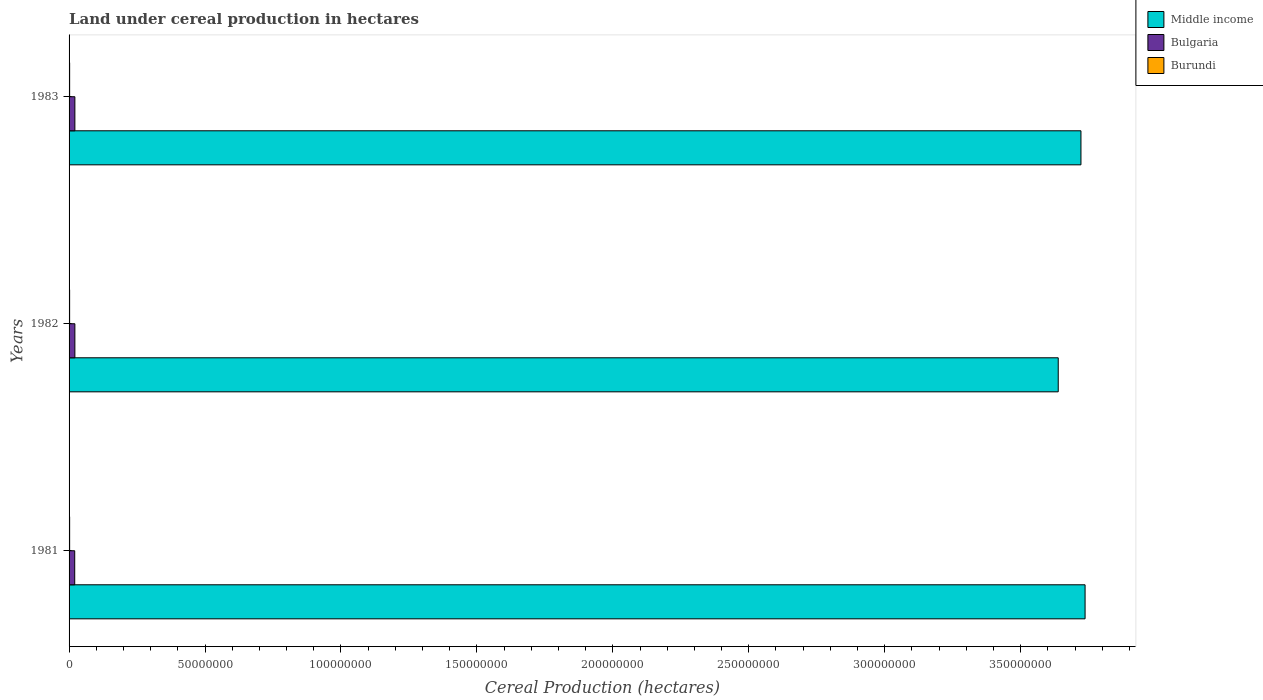How many different coloured bars are there?
Your answer should be very brief. 3. Are the number of bars per tick equal to the number of legend labels?
Offer a very short reply. Yes. Are the number of bars on each tick of the Y-axis equal?
Offer a very short reply. Yes. What is the label of the 3rd group of bars from the top?
Provide a short and direct response. 1981. What is the land under cereal production in Middle income in 1981?
Make the answer very short. 3.74e+08. Across all years, what is the maximum land under cereal production in Burundi?
Make the answer very short. 2.10e+05. Across all years, what is the minimum land under cereal production in Burundi?
Keep it short and to the point. 2.06e+05. What is the total land under cereal production in Middle income in the graph?
Keep it short and to the point. 1.11e+09. What is the difference between the land under cereal production in Bulgaria in 1981 and that in 1982?
Your answer should be compact. -5.45e+04. What is the difference between the land under cereal production in Middle income in 1981 and the land under cereal production in Bulgaria in 1983?
Your answer should be compact. 3.72e+08. What is the average land under cereal production in Middle income per year?
Ensure brevity in your answer.  3.70e+08. In the year 1982, what is the difference between the land under cereal production in Middle income and land under cereal production in Bulgaria?
Make the answer very short. 3.62e+08. What is the ratio of the land under cereal production in Bulgaria in 1982 to that in 1983?
Offer a very short reply. 1. Is the land under cereal production in Burundi in 1981 less than that in 1983?
Give a very brief answer. No. What is the difference between the highest and the second highest land under cereal production in Burundi?
Make the answer very short. 2602. What is the difference between the highest and the lowest land under cereal production in Burundi?
Ensure brevity in your answer.  4602. Is the sum of the land under cereal production in Middle income in 1982 and 1983 greater than the maximum land under cereal production in Burundi across all years?
Make the answer very short. Yes. What does the 1st bar from the top in 1983 represents?
Provide a short and direct response. Burundi. What does the 3rd bar from the bottom in 1983 represents?
Ensure brevity in your answer.  Burundi. Is it the case that in every year, the sum of the land under cereal production in Burundi and land under cereal production in Middle income is greater than the land under cereal production in Bulgaria?
Make the answer very short. Yes. How many bars are there?
Your answer should be very brief. 9. Are all the bars in the graph horizontal?
Keep it short and to the point. Yes. How many years are there in the graph?
Keep it short and to the point. 3. Are the values on the major ticks of X-axis written in scientific E-notation?
Give a very brief answer. No. Does the graph contain any zero values?
Offer a terse response. No. Does the graph contain grids?
Provide a short and direct response. No. What is the title of the graph?
Keep it short and to the point. Land under cereal production in hectares. Does "Dominican Republic" appear as one of the legend labels in the graph?
Your response must be concise. No. What is the label or title of the X-axis?
Give a very brief answer. Cereal Production (hectares). What is the label or title of the Y-axis?
Make the answer very short. Years. What is the Cereal Production (hectares) of Middle income in 1981?
Keep it short and to the point. 3.74e+08. What is the Cereal Production (hectares) in Bulgaria in 1981?
Your answer should be compact. 2.08e+06. What is the Cereal Production (hectares) of Burundi in 1981?
Your answer should be compact. 2.10e+05. What is the Cereal Production (hectares) in Middle income in 1982?
Keep it short and to the point. 3.64e+08. What is the Cereal Production (hectares) of Bulgaria in 1982?
Provide a short and direct response. 2.13e+06. What is the Cereal Production (hectares) in Burundi in 1982?
Your response must be concise. 2.06e+05. What is the Cereal Production (hectares) in Middle income in 1983?
Your answer should be compact. 3.72e+08. What is the Cereal Production (hectares) of Bulgaria in 1983?
Ensure brevity in your answer.  2.13e+06. What is the Cereal Production (hectares) of Burundi in 1983?
Offer a very short reply. 2.08e+05. Across all years, what is the maximum Cereal Production (hectares) in Middle income?
Your answer should be very brief. 3.74e+08. Across all years, what is the maximum Cereal Production (hectares) of Bulgaria?
Your answer should be compact. 2.13e+06. Across all years, what is the maximum Cereal Production (hectares) of Burundi?
Keep it short and to the point. 2.10e+05. Across all years, what is the minimum Cereal Production (hectares) in Middle income?
Offer a very short reply. 3.64e+08. Across all years, what is the minimum Cereal Production (hectares) in Bulgaria?
Your answer should be very brief. 2.08e+06. Across all years, what is the minimum Cereal Production (hectares) of Burundi?
Make the answer very short. 2.06e+05. What is the total Cereal Production (hectares) of Middle income in the graph?
Ensure brevity in your answer.  1.11e+09. What is the total Cereal Production (hectares) of Bulgaria in the graph?
Ensure brevity in your answer.  6.35e+06. What is the total Cereal Production (hectares) in Burundi in the graph?
Give a very brief answer. 6.23e+05. What is the difference between the Cereal Production (hectares) in Middle income in 1981 and that in 1982?
Give a very brief answer. 9.87e+06. What is the difference between the Cereal Production (hectares) of Bulgaria in 1981 and that in 1982?
Offer a terse response. -5.45e+04. What is the difference between the Cereal Production (hectares) in Burundi in 1981 and that in 1982?
Offer a very short reply. 4602. What is the difference between the Cereal Production (hectares) in Middle income in 1981 and that in 1983?
Give a very brief answer. 1.52e+06. What is the difference between the Cereal Production (hectares) in Bulgaria in 1981 and that in 1983?
Your answer should be compact. -5.38e+04. What is the difference between the Cereal Production (hectares) of Burundi in 1981 and that in 1983?
Your answer should be compact. 2602. What is the difference between the Cereal Production (hectares) in Middle income in 1982 and that in 1983?
Provide a short and direct response. -8.36e+06. What is the difference between the Cereal Production (hectares) in Bulgaria in 1982 and that in 1983?
Keep it short and to the point. 752. What is the difference between the Cereal Production (hectares) of Burundi in 1982 and that in 1983?
Ensure brevity in your answer.  -2000. What is the difference between the Cereal Production (hectares) in Middle income in 1981 and the Cereal Production (hectares) in Bulgaria in 1982?
Offer a terse response. 3.72e+08. What is the difference between the Cereal Production (hectares) of Middle income in 1981 and the Cereal Production (hectares) of Burundi in 1982?
Offer a very short reply. 3.74e+08. What is the difference between the Cereal Production (hectares) in Bulgaria in 1981 and the Cereal Production (hectares) in Burundi in 1982?
Ensure brevity in your answer.  1.87e+06. What is the difference between the Cereal Production (hectares) of Middle income in 1981 and the Cereal Production (hectares) of Bulgaria in 1983?
Provide a succinct answer. 3.72e+08. What is the difference between the Cereal Production (hectares) of Middle income in 1981 and the Cereal Production (hectares) of Burundi in 1983?
Provide a succinct answer. 3.74e+08. What is the difference between the Cereal Production (hectares) of Bulgaria in 1981 and the Cereal Production (hectares) of Burundi in 1983?
Keep it short and to the point. 1.87e+06. What is the difference between the Cereal Production (hectares) of Middle income in 1982 and the Cereal Production (hectares) of Bulgaria in 1983?
Make the answer very short. 3.62e+08. What is the difference between the Cereal Production (hectares) of Middle income in 1982 and the Cereal Production (hectares) of Burundi in 1983?
Offer a terse response. 3.64e+08. What is the difference between the Cereal Production (hectares) in Bulgaria in 1982 and the Cereal Production (hectares) in Burundi in 1983?
Give a very brief answer. 1.93e+06. What is the average Cereal Production (hectares) in Middle income per year?
Your answer should be compact. 3.70e+08. What is the average Cereal Production (hectares) of Bulgaria per year?
Offer a very short reply. 2.12e+06. What is the average Cereal Production (hectares) of Burundi per year?
Provide a short and direct response. 2.08e+05. In the year 1981, what is the difference between the Cereal Production (hectares) in Middle income and Cereal Production (hectares) in Bulgaria?
Provide a succinct answer. 3.72e+08. In the year 1981, what is the difference between the Cereal Production (hectares) in Middle income and Cereal Production (hectares) in Burundi?
Offer a very short reply. 3.73e+08. In the year 1981, what is the difference between the Cereal Production (hectares) of Bulgaria and Cereal Production (hectares) of Burundi?
Provide a short and direct response. 1.87e+06. In the year 1982, what is the difference between the Cereal Production (hectares) of Middle income and Cereal Production (hectares) of Bulgaria?
Your response must be concise. 3.62e+08. In the year 1982, what is the difference between the Cereal Production (hectares) in Middle income and Cereal Production (hectares) in Burundi?
Ensure brevity in your answer.  3.64e+08. In the year 1982, what is the difference between the Cereal Production (hectares) of Bulgaria and Cereal Production (hectares) of Burundi?
Keep it short and to the point. 1.93e+06. In the year 1983, what is the difference between the Cereal Production (hectares) of Middle income and Cereal Production (hectares) of Bulgaria?
Provide a succinct answer. 3.70e+08. In the year 1983, what is the difference between the Cereal Production (hectares) in Middle income and Cereal Production (hectares) in Burundi?
Give a very brief answer. 3.72e+08. In the year 1983, what is the difference between the Cereal Production (hectares) in Bulgaria and Cereal Production (hectares) in Burundi?
Provide a short and direct response. 1.93e+06. What is the ratio of the Cereal Production (hectares) of Middle income in 1981 to that in 1982?
Your answer should be very brief. 1.03. What is the ratio of the Cereal Production (hectares) of Bulgaria in 1981 to that in 1982?
Keep it short and to the point. 0.97. What is the ratio of the Cereal Production (hectares) of Burundi in 1981 to that in 1982?
Ensure brevity in your answer.  1.02. What is the ratio of the Cereal Production (hectares) of Middle income in 1981 to that in 1983?
Keep it short and to the point. 1. What is the ratio of the Cereal Production (hectares) in Bulgaria in 1981 to that in 1983?
Make the answer very short. 0.97. What is the ratio of the Cereal Production (hectares) in Burundi in 1981 to that in 1983?
Your response must be concise. 1.01. What is the ratio of the Cereal Production (hectares) in Middle income in 1982 to that in 1983?
Your response must be concise. 0.98. What is the ratio of the Cereal Production (hectares) in Bulgaria in 1982 to that in 1983?
Ensure brevity in your answer.  1. What is the difference between the highest and the second highest Cereal Production (hectares) of Middle income?
Offer a terse response. 1.52e+06. What is the difference between the highest and the second highest Cereal Production (hectares) in Bulgaria?
Ensure brevity in your answer.  752. What is the difference between the highest and the second highest Cereal Production (hectares) of Burundi?
Your answer should be compact. 2602. What is the difference between the highest and the lowest Cereal Production (hectares) in Middle income?
Ensure brevity in your answer.  9.87e+06. What is the difference between the highest and the lowest Cereal Production (hectares) in Bulgaria?
Offer a terse response. 5.45e+04. What is the difference between the highest and the lowest Cereal Production (hectares) of Burundi?
Your answer should be very brief. 4602. 